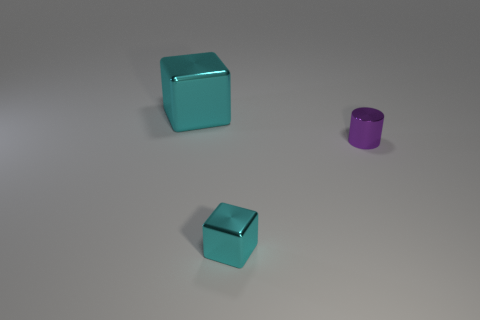Add 2 big blocks. How many objects exist? 5 Subtract all blocks. How many objects are left? 1 Add 3 brown cylinders. How many brown cylinders exist? 3 Subtract 0 cyan cylinders. How many objects are left? 3 Subtract all big gray metallic cubes. Subtract all big metal cubes. How many objects are left? 2 Add 2 purple cylinders. How many purple cylinders are left? 3 